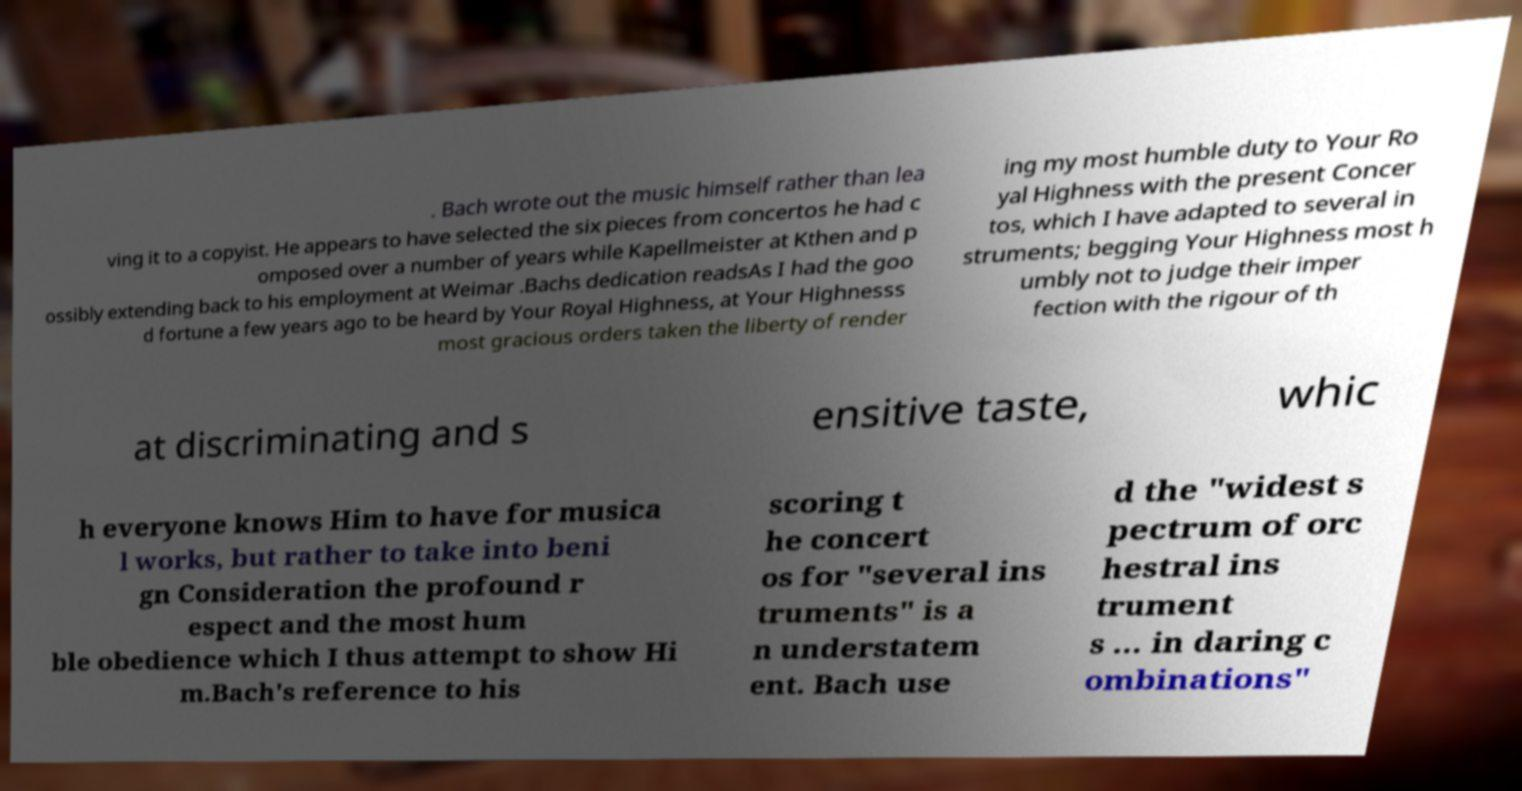There's text embedded in this image that I need extracted. Can you transcribe it verbatim? . Bach wrote out the music himself rather than lea ving it to a copyist. He appears to have selected the six pieces from concertos he had c omposed over a number of years while Kapellmeister at Kthen and p ossibly extending back to his employment at Weimar .Bachs dedication readsAs I had the goo d fortune a few years ago to be heard by Your Royal Highness, at Your Highnesss most gracious orders taken the liberty of render ing my most humble duty to Your Ro yal Highness with the present Concer tos, which I have adapted to several in struments; begging Your Highness most h umbly not to judge their imper fection with the rigour of th at discriminating and s ensitive taste, whic h everyone knows Him to have for musica l works, but rather to take into beni gn Consideration the profound r espect and the most hum ble obedience which I thus attempt to show Hi m.Bach's reference to his scoring t he concert os for "several ins truments" is a n understatem ent. Bach use d the "widest s pectrum of orc hestral ins trument s … in daring c ombinations" 